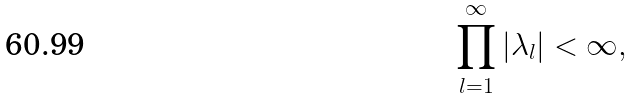<formula> <loc_0><loc_0><loc_500><loc_500>\prod _ { l = 1 } ^ { \infty } | \lambda _ { l } | < \infty ,</formula> 